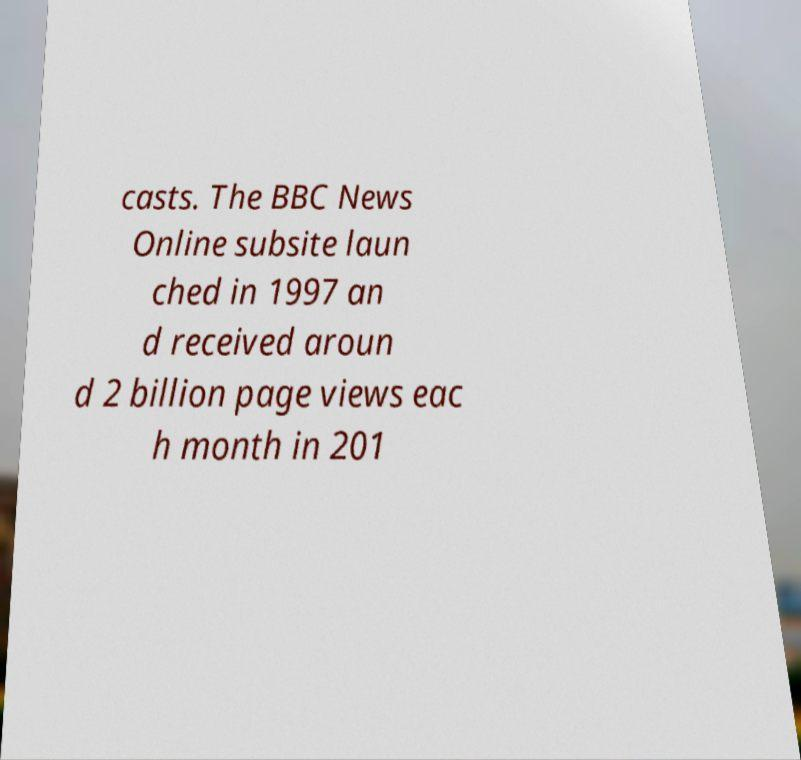Could you extract and type out the text from this image? casts. The BBC News Online subsite laun ched in 1997 an d received aroun d 2 billion page views eac h month in 201 